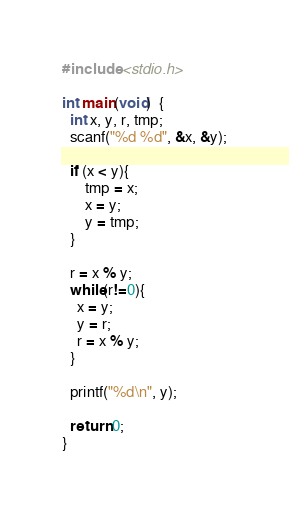<code> <loc_0><loc_0><loc_500><loc_500><_C_>#include <stdio.h>

int main(void)  {
  int x, y, r, tmp;
  scanf("%d %d", &x, &y);

  if (x < y){
      tmp = x;
      x = y;
      y = tmp;
  }
 
  r = x % y;
  while(r!=0){
    x = y;
    y = r;
    r = x % y;
  }

  printf("%d\n", y);

  return 0;
}</code> 